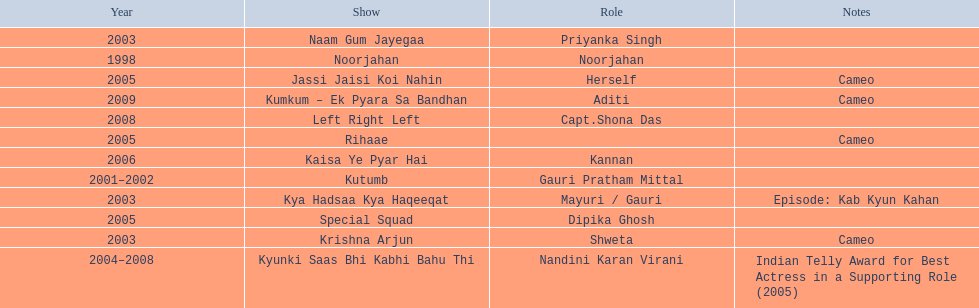The shows with at most 1 cameo Krishna Arjun, Rihaae, Jassi Jaisi Koi Nahin, Kumkum - Ek Pyara Sa Bandhan. 